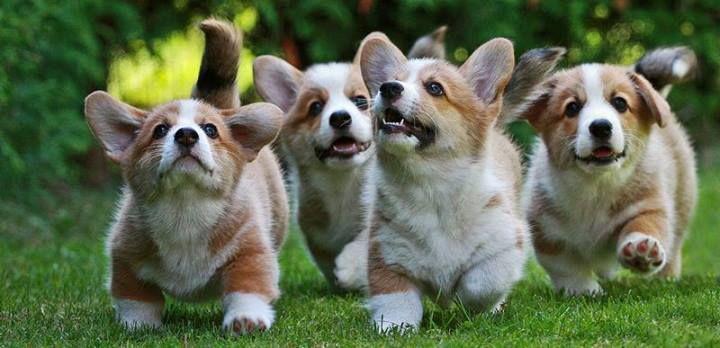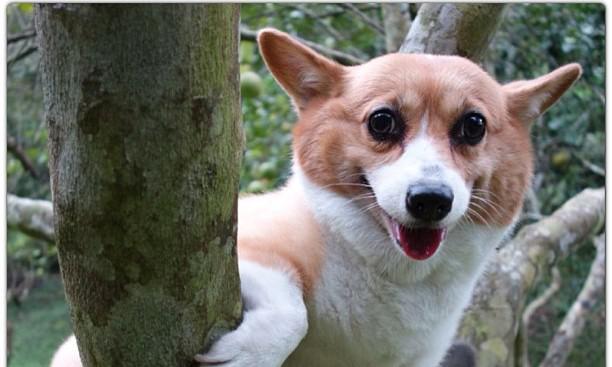The first image is the image on the left, the second image is the image on the right. Assess this claim about the two images: "There are no more than 7 dogs in total.". Correct or not? Answer yes or no. Yes. 